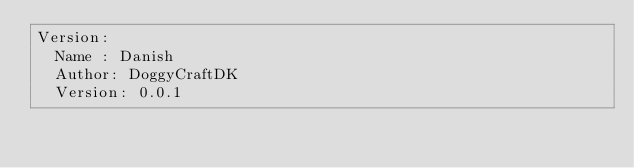Convert code to text. <code><loc_0><loc_0><loc_500><loc_500><_YAML_>Version:
  Name : Danish
  Author: DoggyCraftDK
  Version: 0.0.1</code> 